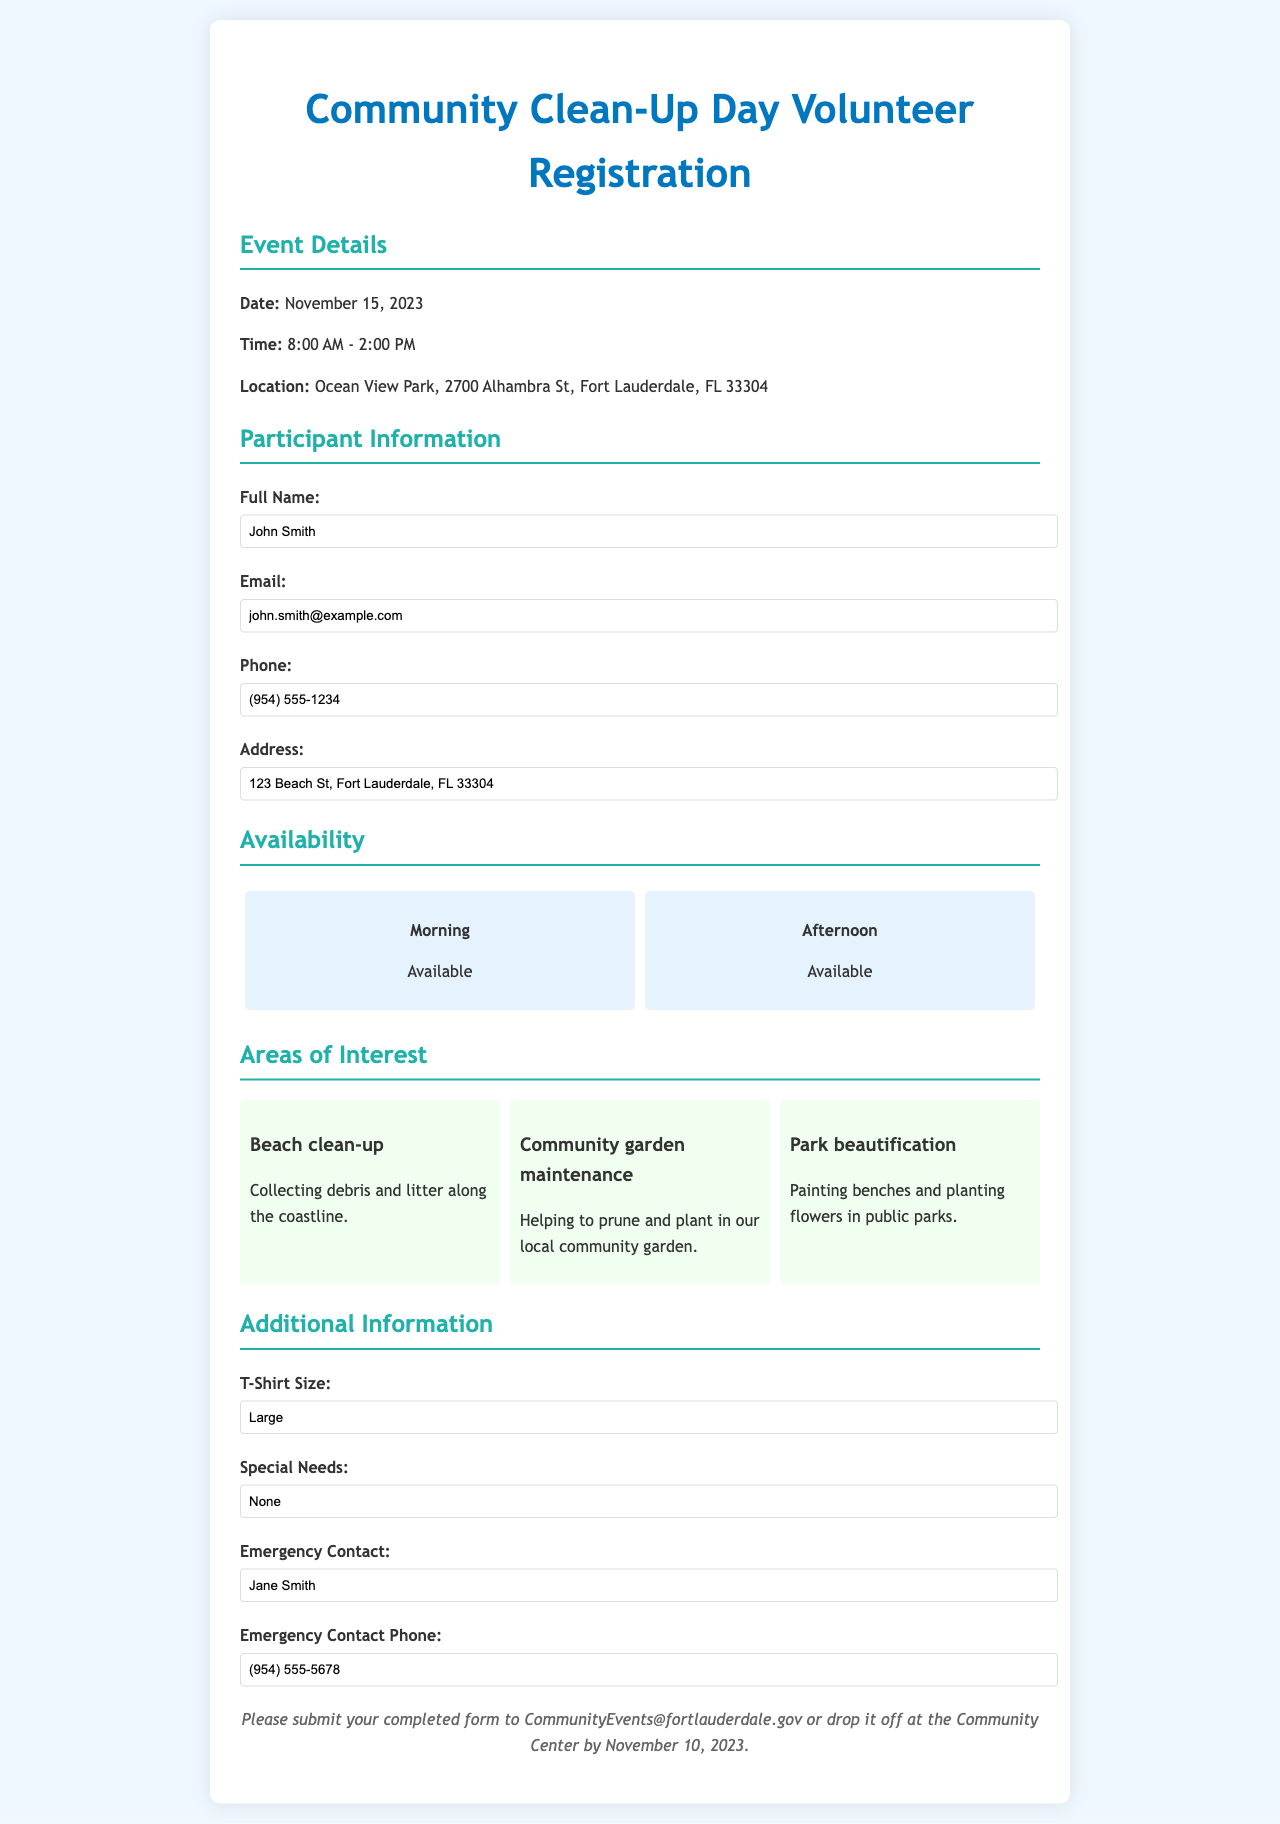What is the date of the event? The date of the event is explicitly listed in the document.
Answer: November 15, 2023 What is the participant's full name? The participant's full name is provided in the participant information section of the document.
Answer: John Smith What time does the event start? The starting time for the event is stated in the details section of the document.
Answer: 8:00 AM Which areas of interest is the participant interested in? The document lists the areas of interest as options for volunteering participation.
Answer: Beach clean-up, Community garden maintenance, Park beautification What is the emergency contact's name? The emergency contact's name is found in the additional information section of the document.
Answer: Jane Smith What is the phone number of the participant? The phone number for the participant is given in the participant information section.
Answer: (954) 555-1234 Is the participant available in the afternoon? The availability information shows the time slots the participant is available for the event.
Answer: Available What is the participant's T-shirt size? The T-shirt size that the participant selected is found in the additional information section.
Answer: Large What is the location of the event? The location is clearly detailed in the event details section of the document.
Answer: Ocean View Park, 2700 Alhambra St, Fort Lauderdale, FL 33304 